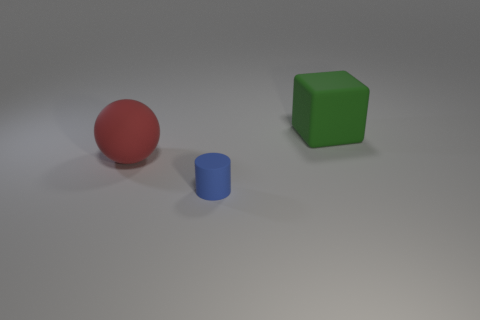Subtract 1 cubes. How many cubes are left? 0 Add 2 big red objects. How many objects exist? 5 Subtract all balls. How many objects are left? 2 Subtract all cyan cylinders. How many yellow balls are left? 0 Subtract all brown balls. Subtract all red cubes. How many balls are left? 1 Subtract all small purple matte cubes. Subtract all large rubber things. How many objects are left? 1 Add 1 tiny rubber objects. How many tiny rubber objects are left? 2 Add 3 brown matte cylinders. How many brown matte cylinders exist? 3 Subtract 0 green cylinders. How many objects are left? 3 